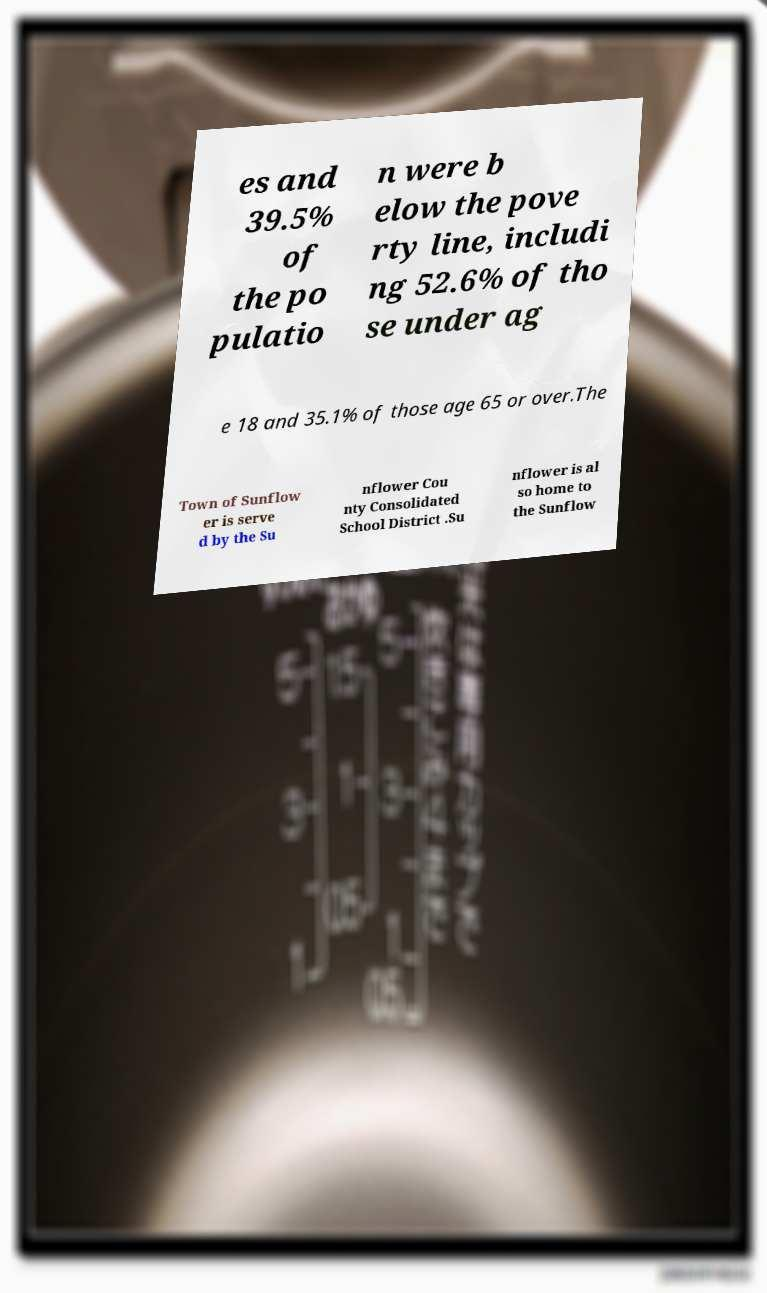For documentation purposes, I need the text within this image transcribed. Could you provide that? es and 39.5% of the po pulatio n were b elow the pove rty line, includi ng 52.6% of tho se under ag e 18 and 35.1% of those age 65 or over.The Town of Sunflow er is serve d by the Su nflower Cou nty Consolidated School District .Su nflower is al so home to the Sunflow 